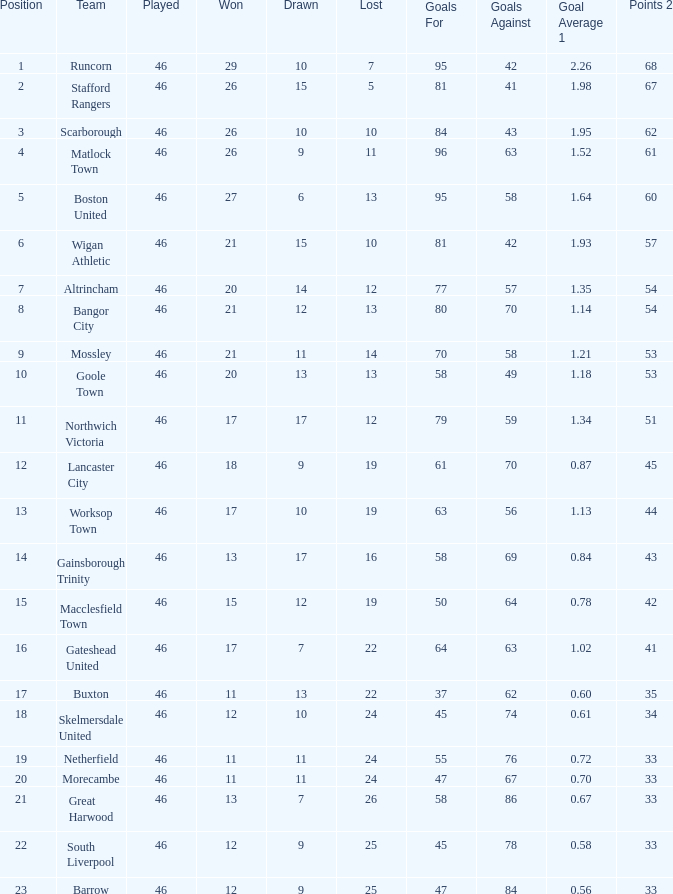List every loss having a mean of 14.0. 